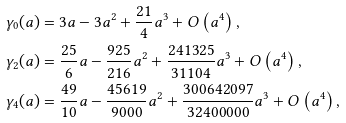<formula> <loc_0><loc_0><loc_500><loc_500>\gamma _ { 0 } ( a ) & = 3 a - 3 a ^ { 2 } + \frac { 2 1 } { 4 } a ^ { 3 } + O \left ( a ^ { 4 } \right ) , \\ \gamma _ { 2 } ( a ) & = \frac { 2 5 } { 6 } a - \frac { 9 2 5 } { 2 1 6 } a ^ { 2 } + \frac { 2 4 1 3 2 5 } { 3 1 1 0 4 } a ^ { 3 } + O \left ( a ^ { 4 } \right ) , \\ \gamma _ { 4 } ( a ) & = \frac { 4 9 } { 1 0 } a - \frac { 4 5 6 1 9 } { 9 0 0 0 } a ^ { 2 } + \frac { 3 0 0 6 4 2 0 9 7 } { 3 2 4 0 0 0 0 0 } a ^ { 3 } + O \left ( a ^ { 4 } \right ) ,</formula> 